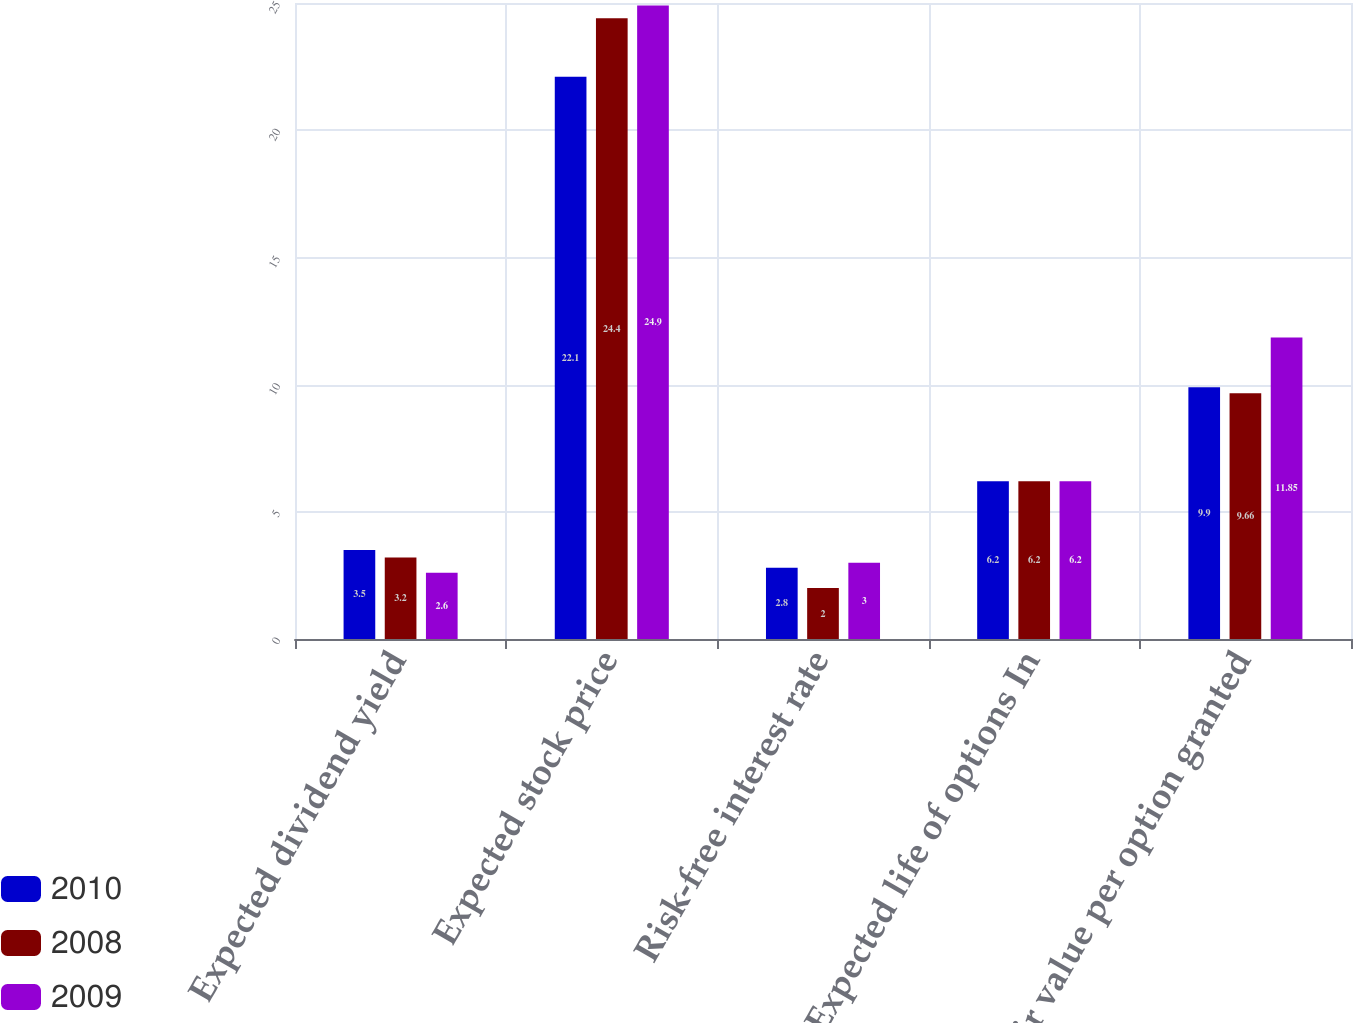<chart> <loc_0><loc_0><loc_500><loc_500><stacked_bar_chart><ecel><fcel>Expected dividend yield<fcel>Expected stock price<fcel>Risk-free interest rate<fcel>Expected life of options In<fcel>Fair value per option granted<nl><fcel>2010<fcel>3.5<fcel>22.1<fcel>2.8<fcel>6.2<fcel>9.9<nl><fcel>2008<fcel>3.2<fcel>24.4<fcel>2<fcel>6.2<fcel>9.66<nl><fcel>2009<fcel>2.6<fcel>24.9<fcel>3<fcel>6.2<fcel>11.85<nl></chart> 